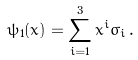Convert formula to latex. <formula><loc_0><loc_0><loc_500><loc_500>\psi _ { 1 } ( x ) = \sum _ { i = 1 } ^ { 3 } x ^ { i } \sigma _ { i } \, .</formula> 